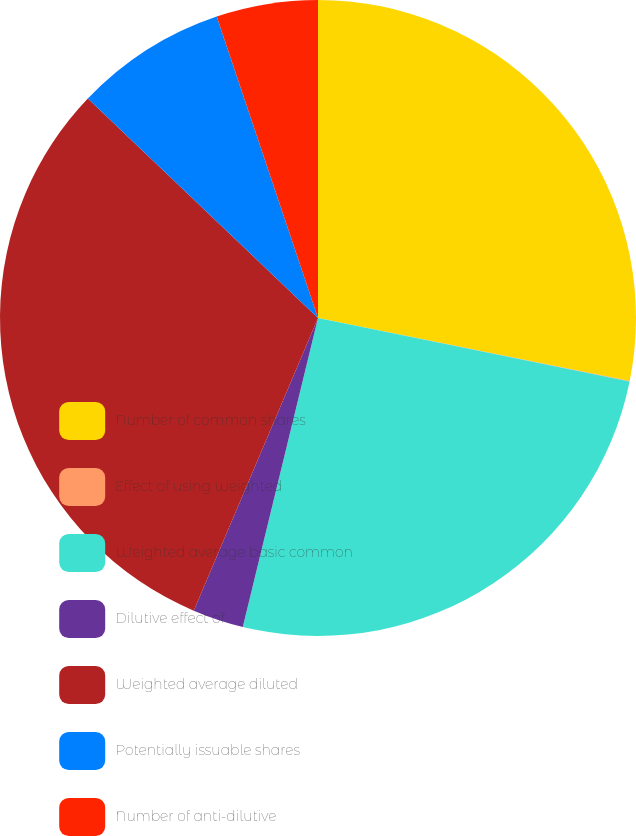Convert chart to OTSL. <chart><loc_0><loc_0><loc_500><loc_500><pie_chart><fcel>Number of common shares<fcel>Effect of using weighted<fcel>Weighted average basic common<fcel>Dilutive effect of<fcel>Weighted average diluted<fcel>Potentially issuable shares<fcel>Number of anti-dilutive<nl><fcel>28.17%<fcel>0.03%<fcel>25.6%<fcel>2.59%<fcel>30.73%<fcel>7.72%<fcel>5.16%<nl></chart> 